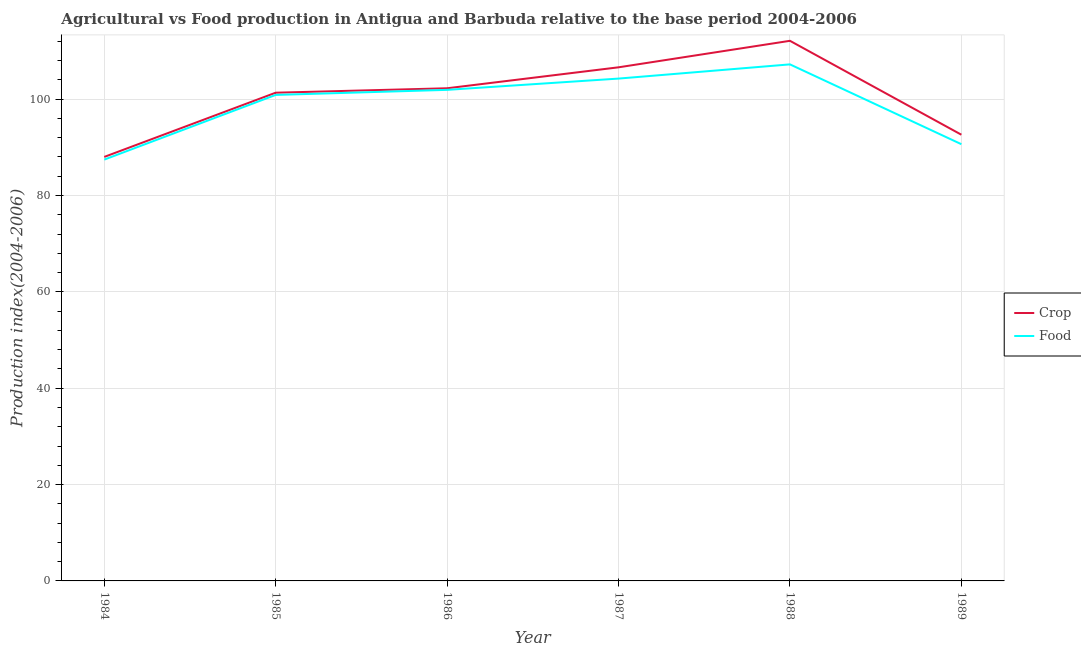Is the number of lines equal to the number of legend labels?
Make the answer very short. Yes. What is the food production index in 1987?
Make the answer very short. 104.27. Across all years, what is the maximum food production index?
Keep it short and to the point. 107.22. Across all years, what is the minimum food production index?
Your answer should be very brief. 87.45. In which year was the food production index maximum?
Give a very brief answer. 1988. What is the total food production index in the graph?
Give a very brief answer. 592.4. What is the difference between the food production index in 1988 and that in 1989?
Give a very brief answer. 16.57. What is the difference between the crop production index in 1987 and the food production index in 1984?
Keep it short and to the point. 19.16. What is the average food production index per year?
Keep it short and to the point. 98.73. In the year 1987, what is the difference between the food production index and crop production index?
Your answer should be compact. -2.34. In how many years, is the crop production index greater than 24?
Give a very brief answer. 6. What is the ratio of the food production index in 1984 to that in 1989?
Keep it short and to the point. 0.96. What is the difference between the highest and the second highest food production index?
Keep it short and to the point. 2.95. What is the difference between the highest and the lowest food production index?
Keep it short and to the point. 19.77. In how many years, is the crop production index greater than the average crop production index taken over all years?
Your answer should be very brief. 4. Is the crop production index strictly greater than the food production index over the years?
Your response must be concise. Yes. Is the crop production index strictly less than the food production index over the years?
Ensure brevity in your answer.  No. How many lines are there?
Your answer should be compact. 2. How many years are there in the graph?
Your answer should be very brief. 6. Where does the legend appear in the graph?
Provide a short and direct response. Center right. How are the legend labels stacked?
Your response must be concise. Vertical. What is the title of the graph?
Offer a very short reply. Agricultural vs Food production in Antigua and Barbuda relative to the base period 2004-2006. What is the label or title of the X-axis?
Your response must be concise. Year. What is the label or title of the Y-axis?
Offer a very short reply. Production index(2004-2006). What is the Production index(2004-2006) in Crop in 1984?
Ensure brevity in your answer.  88.01. What is the Production index(2004-2006) in Food in 1984?
Provide a succinct answer. 87.45. What is the Production index(2004-2006) in Crop in 1985?
Give a very brief answer. 101.34. What is the Production index(2004-2006) in Food in 1985?
Ensure brevity in your answer.  100.88. What is the Production index(2004-2006) in Crop in 1986?
Offer a very short reply. 102.26. What is the Production index(2004-2006) in Food in 1986?
Your answer should be very brief. 101.93. What is the Production index(2004-2006) in Crop in 1987?
Provide a short and direct response. 106.61. What is the Production index(2004-2006) in Food in 1987?
Provide a succinct answer. 104.27. What is the Production index(2004-2006) of Crop in 1988?
Provide a succinct answer. 112.11. What is the Production index(2004-2006) of Food in 1988?
Provide a succinct answer. 107.22. What is the Production index(2004-2006) in Crop in 1989?
Your answer should be compact. 92.62. What is the Production index(2004-2006) in Food in 1989?
Your response must be concise. 90.65. Across all years, what is the maximum Production index(2004-2006) in Crop?
Give a very brief answer. 112.11. Across all years, what is the maximum Production index(2004-2006) of Food?
Provide a short and direct response. 107.22. Across all years, what is the minimum Production index(2004-2006) in Crop?
Your answer should be compact. 88.01. Across all years, what is the minimum Production index(2004-2006) in Food?
Keep it short and to the point. 87.45. What is the total Production index(2004-2006) in Crop in the graph?
Provide a short and direct response. 602.95. What is the total Production index(2004-2006) in Food in the graph?
Provide a succinct answer. 592.4. What is the difference between the Production index(2004-2006) in Crop in 1984 and that in 1985?
Offer a terse response. -13.33. What is the difference between the Production index(2004-2006) of Food in 1984 and that in 1985?
Your response must be concise. -13.43. What is the difference between the Production index(2004-2006) in Crop in 1984 and that in 1986?
Make the answer very short. -14.25. What is the difference between the Production index(2004-2006) of Food in 1984 and that in 1986?
Keep it short and to the point. -14.48. What is the difference between the Production index(2004-2006) of Crop in 1984 and that in 1987?
Give a very brief answer. -18.6. What is the difference between the Production index(2004-2006) of Food in 1984 and that in 1987?
Ensure brevity in your answer.  -16.82. What is the difference between the Production index(2004-2006) in Crop in 1984 and that in 1988?
Give a very brief answer. -24.1. What is the difference between the Production index(2004-2006) of Food in 1984 and that in 1988?
Your answer should be compact. -19.77. What is the difference between the Production index(2004-2006) of Crop in 1984 and that in 1989?
Provide a succinct answer. -4.61. What is the difference between the Production index(2004-2006) in Food in 1984 and that in 1989?
Your answer should be compact. -3.2. What is the difference between the Production index(2004-2006) in Crop in 1985 and that in 1986?
Ensure brevity in your answer.  -0.92. What is the difference between the Production index(2004-2006) in Food in 1985 and that in 1986?
Offer a very short reply. -1.05. What is the difference between the Production index(2004-2006) of Crop in 1985 and that in 1987?
Provide a short and direct response. -5.27. What is the difference between the Production index(2004-2006) in Food in 1985 and that in 1987?
Make the answer very short. -3.39. What is the difference between the Production index(2004-2006) of Crop in 1985 and that in 1988?
Provide a short and direct response. -10.77. What is the difference between the Production index(2004-2006) of Food in 1985 and that in 1988?
Ensure brevity in your answer.  -6.34. What is the difference between the Production index(2004-2006) in Crop in 1985 and that in 1989?
Provide a short and direct response. 8.72. What is the difference between the Production index(2004-2006) in Food in 1985 and that in 1989?
Ensure brevity in your answer.  10.23. What is the difference between the Production index(2004-2006) in Crop in 1986 and that in 1987?
Keep it short and to the point. -4.35. What is the difference between the Production index(2004-2006) of Food in 1986 and that in 1987?
Give a very brief answer. -2.34. What is the difference between the Production index(2004-2006) of Crop in 1986 and that in 1988?
Ensure brevity in your answer.  -9.85. What is the difference between the Production index(2004-2006) in Food in 1986 and that in 1988?
Provide a short and direct response. -5.29. What is the difference between the Production index(2004-2006) of Crop in 1986 and that in 1989?
Offer a terse response. 9.64. What is the difference between the Production index(2004-2006) in Food in 1986 and that in 1989?
Your answer should be very brief. 11.28. What is the difference between the Production index(2004-2006) of Crop in 1987 and that in 1988?
Your response must be concise. -5.5. What is the difference between the Production index(2004-2006) in Food in 1987 and that in 1988?
Make the answer very short. -2.95. What is the difference between the Production index(2004-2006) in Crop in 1987 and that in 1989?
Give a very brief answer. 13.99. What is the difference between the Production index(2004-2006) of Food in 1987 and that in 1989?
Your answer should be very brief. 13.62. What is the difference between the Production index(2004-2006) in Crop in 1988 and that in 1989?
Your answer should be compact. 19.49. What is the difference between the Production index(2004-2006) in Food in 1988 and that in 1989?
Provide a short and direct response. 16.57. What is the difference between the Production index(2004-2006) in Crop in 1984 and the Production index(2004-2006) in Food in 1985?
Provide a short and direct response. -12.87. What is the difference between the Production index(2004-2006) in Crop in 1984 and the Production index(2004-2006) in Food in 1986?
Keep it short and to the point. -13.92. What is the difference between the Production index(2004-2006) of Crop in 1984 and the Production index(2004-2006) of Food in 1987?
Your response must be concise. -16.26. What is the difference between the Production index(2004-2006) of Crop in 1984 and the Production index(2004-2006) of Food in 1988?
Your response must be concise. -19.21. What is the difference between the Production index(2004-2006) of Crop in 1984 and the Production index(2004-2006) of Food in 1989?
Provide a succinct answer. -2.64. What is the difference between the Production index(2004-2006) in Crop in 1985 and the Production index(2004-2006) in Food in 1986?
Offer a terse response. -0.59. What is the difference between the Production index(2004-2006) of Crop in 1985 and the Production index(2004-2006) of Food in 1987?
Make the answer very short. -2.93. What is the difference between the Production index(2004-2006) in Crop in 1985 and the Production index(2004-2006) in Food in 1988?
Offer a very short reply. -5.88. What is the difference between the Production index(2004-2006) in Crop in 1985 and the Production index(2004-2006) in Food in 1989?
Keep it short and to the point. 10.69. What is the difference between the Production index(2004-2006) of Crop in 1986 and the Production index(2004-2006) of Food in 1987?
Provide a short and direct response. -2.01. What is the difference between the Production index(2004-2006) in Crop in 1986 and the Production index(2004-2006) in Food in 1988?
Keep it short and to the point. -4.96. What is the difference between the Production index(2004-2006) of Crop in 1986 and the Production index(2004-2006) of Food in 1989?
Ensure brevity in your answer.  11.61. What is the difference between the Production index(2004-2006) of Crop in 1987 and the Production index(2004-2006) of Food in 1988?
Your answer should be very brief. -0.61. What is the difference between the Production index(2004-2006) of Crop in 1987 and the Production index(2004-2006) of Food in 1989?
Your response must be concise. 15.96. What is the difference between the Production index(2004-2006) of Crop in 1988 and the Production index(2004-2006) of Food in 1989?
Keep it short and to the point. 21.46. What is the average Production index(2004-2006) in Crop per year?
Give a very brief answer. 100.49. What is the average Production index(2004-2006) of Food per year?
Make the answer very short. 98.73. In the year 1984, what is the difference between the Production index(2004-2006) in Crop and Production index(2004-2006) in Food?
Keep it short and to the point. 0.56. In the year 1985, what is the difference between the Production index(2004-2006) in Crop and Production index(2004-2006) in Food?
Your answer should be compact. 0.46. In the year 1986, what is the difference between the Production index(2004-2006) of Crop and Production index(2004-2006) of Food?
Your answer should be very brief. 0.33. In the year 1987, what is the difference between the Production index(2004-2006) in Crop and Production index(2004-2006) in Food?
Your answer should be very brief. 2.34. In the year 1988, what is the difference between the Production index(2004-2006) of Crop and Production index(2004-2006) of Food?
Give a very brief answer. 4.89. In the year 1989, what is the difference between the Production index(2004-2006) in Crop and Production index(2004-2006) in Food?
Your response must be concise. 1.97. What is the ratio of the Production index(2004-2006) of Crop in 1984 to that in 1985?
Offer a terse response. 0.87. What is the ratio of the Production index(2004-2006) of Food in 1984 to that in 1985?
Offer a terse response. 0.87. What is the ratio of the Production index(2004-2006) of Crop in 1984 to that in 1986?
Make the answer very short. 0.86. What is the ratio of the Production index(2004-2006) of Food in 1984 to that in 1986?
Your answer should be very brief. 0.86. What is the ratio of the Production index(2004-2006) in Crop in 1984 to that in 1987?
Offer a terse response. 0.83. What is the ratio of the Production index(2004-2006) of Food in 1984 to that in 1987?
Ensure brevity in your answer.  0.84. What is the ratio of the Production index(2004-2006) of Crop in 1984 to that in 1988?
Your response must be concise. 0.79. What is the ratio of the Production index(2004-2006) of Food in 1984 to that in 1988?
Offer a terse response. 0.82. What is the ratio of the Production index(2004-2006) of Crop in 1984 to that in 1989?
Provide a succinct answer. 0.95. What is the ratio of the Production index(2004-2006) of Food in 1984 to that in 1989?
Offer a terse response. 0.96. What is the ratio of the Production index(2004-2006) of Crop in 1985 to that in 1986?
Your answer should be very brief. 0.99. What is the ratio of the Production index(2004-2006) in Crop in 1985 to that in 1987?
Provide a succinct answer. 0.95. What is the ratio of the Production index(2004-2006) of Food in 1985 to that in 1987?
Provide a short and direct response. 0.97. What is the ratio of the Production index(2004-2006) of Crop in 1985 to that in 1988?
Give a very brief answer. 0.9. What is the ratio of the Production index(2004-2006) of Food in 1985 to that in 1988?
Your response must be concise. 0.94. What is the ratio of the Production index(2004-2006) of Crop in 1985 to that in 1989?
Make the answer very short. 1.09. What is the ratio of the Production index(2004-2006) of Food in 1985 to that in 1989?
Offer a terse response. 1.11. What is the ratio of the Production index(2004-2006) in Crop in 1986 to that in 1987?
Provide a succinct answer. 0.96. What is the ratio of the Production index(2004-2006) in Food in 1986 to that in 1987?
Give a very brief answer. 0.98. What is the ratio of the Production index(2004-2006) of Crop in 1986 to that in 1988?
Offer a very short reply. 0.91. What is the ratio of the Production index(2004-2006) in Food in 1986 to that in 1988?
Provide a short and direct response. 0.95. What is the ratio of the Production index(2004-2006) in Crop in 1986 to that in 1989?
Your answer should be compact. 1.1. What is the ratio of the Production index(2004-2006) of Food in 1986 to that in 1989?
Keep it short and to the point. 1.12. What is the ratio of the Production index(2004-2006) of Crop in 1987 to that in 1988?
Ensure brevity in your answer.  0.95. What is the ratio of the Production index(2004-2006) of Food in 1987 to that in 1988?
Provide a succinct answer. 0.97. What is the ratio of the Production index(2004-2006) of Crop in 1987 to that in 1989?
Keep it short and to the point. 1.15. What is the ratio of the Production index(2004-2006) in Food in 1987 to that in 1989?
Ensure brevity in your answer.  1.15. What is the ratio of the Production index(2004-2006) of Crop in 1988 to that in 1989?
Provide a succinct answer. 1.21. What is the ratio of the Production index(2004-2006) in Food in 1988 to that in 1989?
Offer a terse response. 1.18. What is the difference between the highest and the second highest Production index(2004-2006) of Food?
Give a very brief answer. 2.95. What is the difference between the highest and the lowest Production index(2004-2006) of Crop?
Give a very brief answer. 24.1. What is the difference between the highest and the lowest Production index(2004-2006) of Food?
Your answer should be very brief. 19.77. 